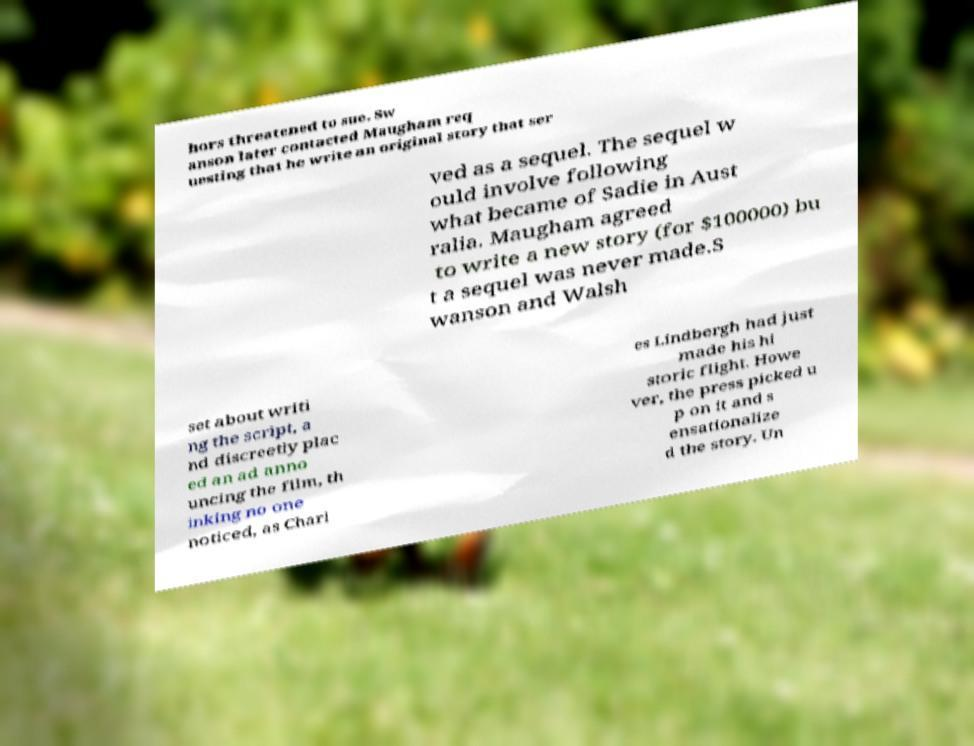Could you extract and type out the text from this image? hors threatened to sue. Sw anson later contacted Maugham req uesting that he write an original story that ser ved as a sequel. The sequel w ould involve following what became of Sadie in Aust ralia. Maugham agreed to write a new story (for $100000) bu t a sequel was never made.S wanson and Walsh set about writi ng the script, a nd discreetly plac ed an ad anno uncing the film, th inking no one noticed, as Charl es Lindbergh had just made his hi storic flight. Howe ver, the press picked u p on it and s ensationalize d the story. Un 